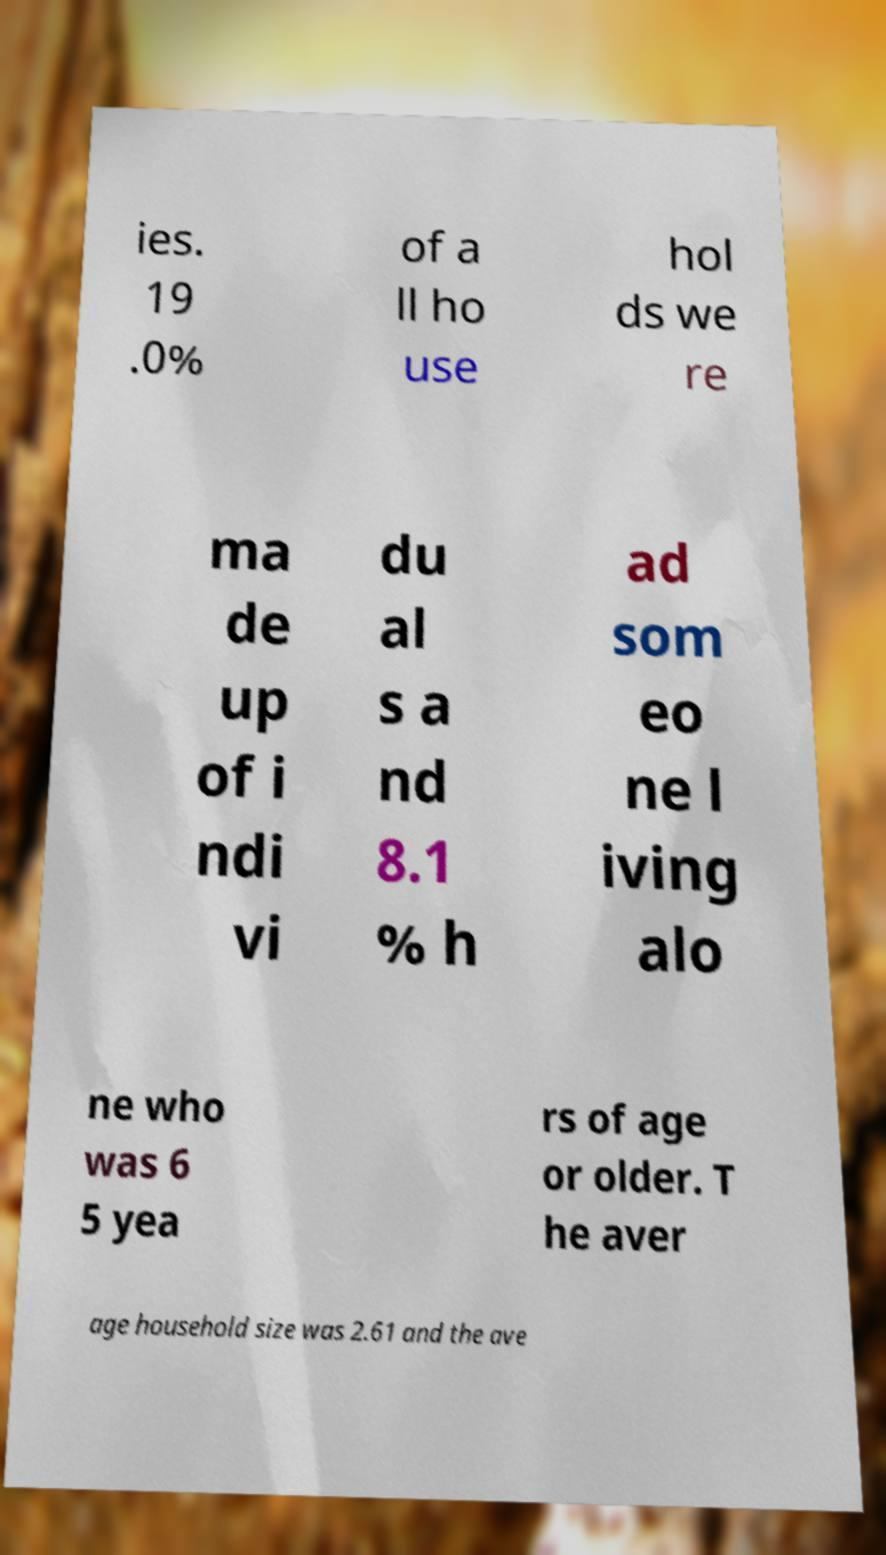Please read and relay the text visible in this image. What does it say? ies. 19 .0% of a ll ho use hol ds we re ma de up of i ndi vi du al s a nd 8.1 % h ad som eo ne l iving alo ne who was 6 5 yea rs of age or older. T he aver age household size was 2.61 and the ave 